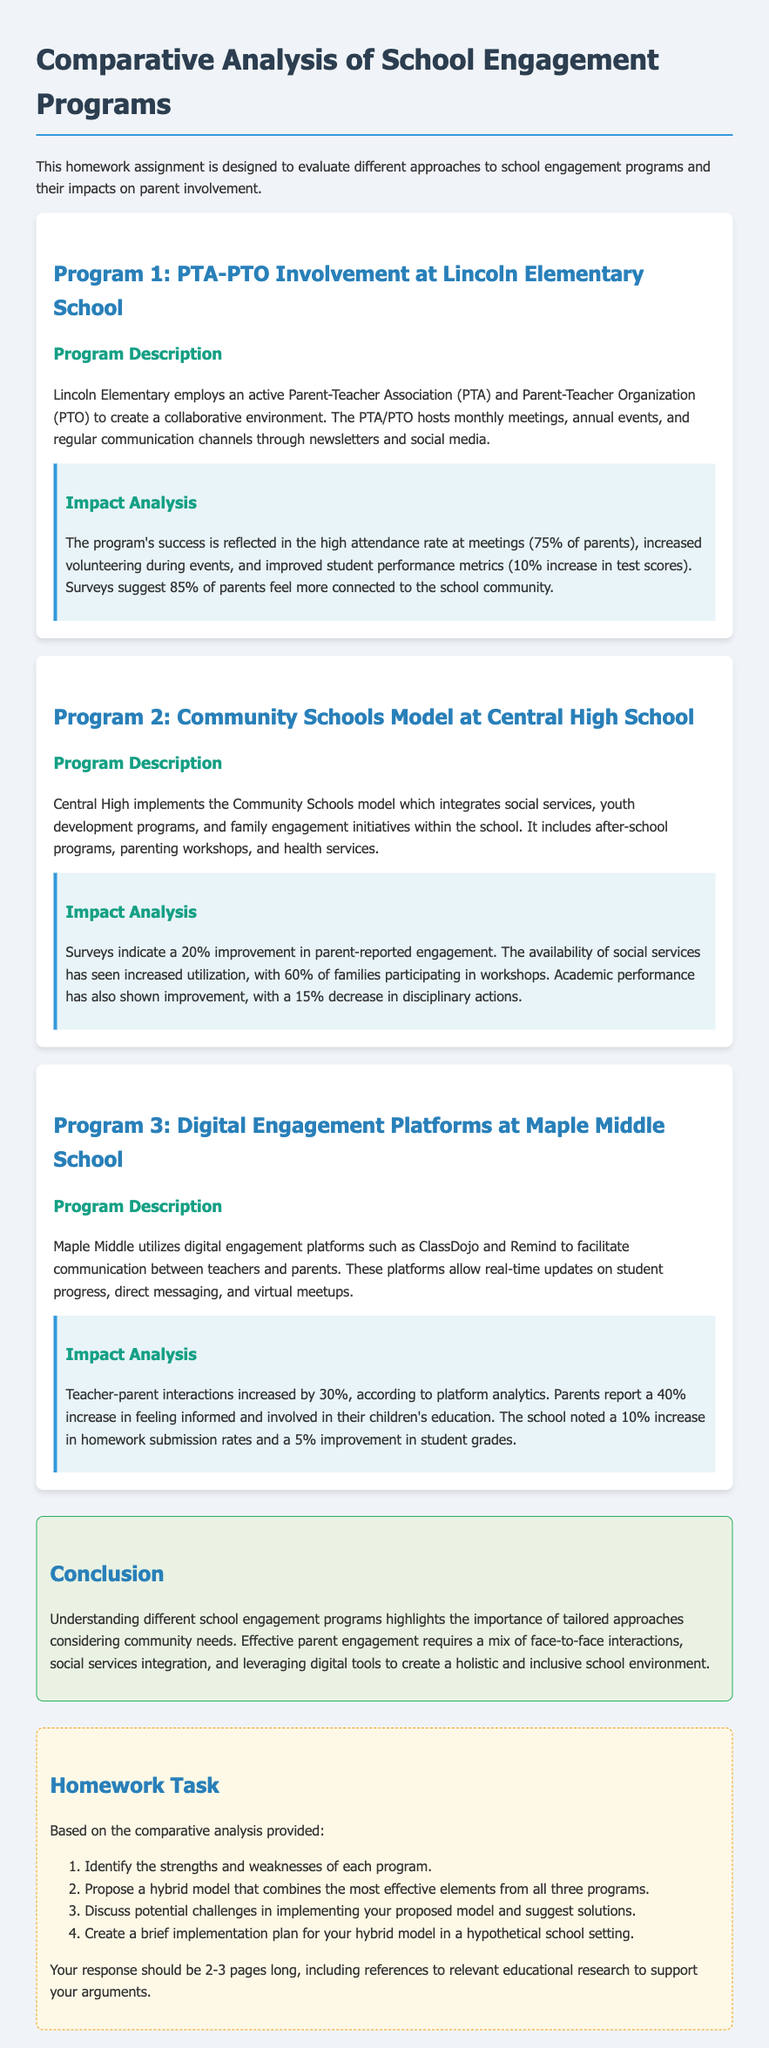What is the attendance rate at Lincoln Elementary's PTA/PTO meetings? The attendance rate at Lincoln Elementary's PTA/PTO meetings is provided as a specific percentage in the document.
Answer: 75% What percentage of parents at Lincoln Elementary feel more connected to the school community? The document states a specific percentage of parents who feel more connected to the school community at Lincoln Elementary.
Answer: 85% What model does Central High School implement for parent engagement? The document describes the specific model used at Central High School for engaging parents, referring to its structured approach.
Answer: Community Schools model How much did parental engagement improve according to surveys at Central High School? The document provides a numerical value reflecting the improvement in parent-reported engagement at Central High School, indicating the percentage increase.
Answer: 20% What was the increase in teacher-parent interactions at Maple Middle School? The document quantifies the increase in teacher-parent interactions at Maple Middle School using a specific percentage reflecting the change.
Answer: 30% What improvement did parents report in feeling informed and involved at Maple Middle School? The document cites a specific percentage indicating how much parents felt more informed and involved in their children’s education at Maple Middle School.
Answer: 40% What is suggested as a potential challenge in implementing the proposed hybrid model? The homework task prompts for challenges that may arise in implementing a new model, encouraging critical thinking about specific issues.
Answer: Challenges What is the overall goal of the homework task? The document outlines the purpose of the homework task, which involves analyzing and proposing strategies for school engagement.
Answer: Analyze and propose strategies How many pages should the homework response be? The document specifies the expected length of the homework response in terms of pages, guiding students on the project scope.
Answer: 2-3 pages 